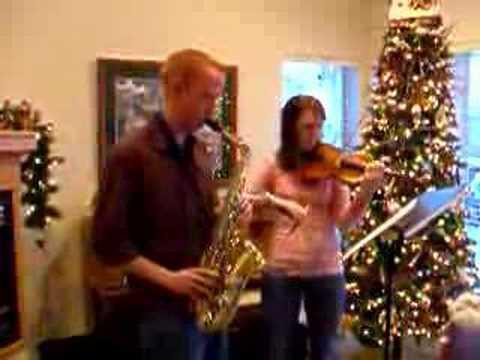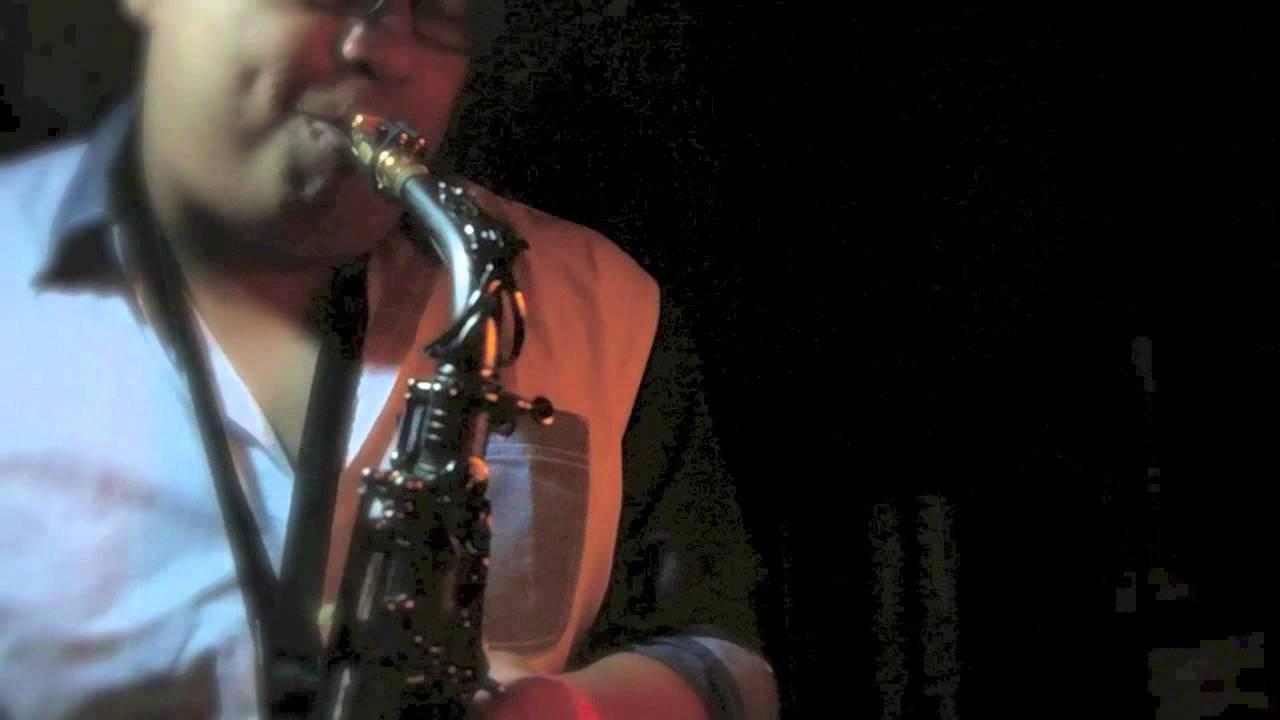The first image is the image on the left, the second image is the image on the right. Examine the images to the left and right. Is the description "The lefthand image includes a woman in a cleavage-baring dress standing and holding a saxophone in front of a woman standing and playing violin." accurate? Answer yes or no. No. The first image is the image on the left, the second image is the image on the right. Assess this claim about the two images: "There are exactly two people in the left image.". Correct or not? Answer yes or no. Yes. 